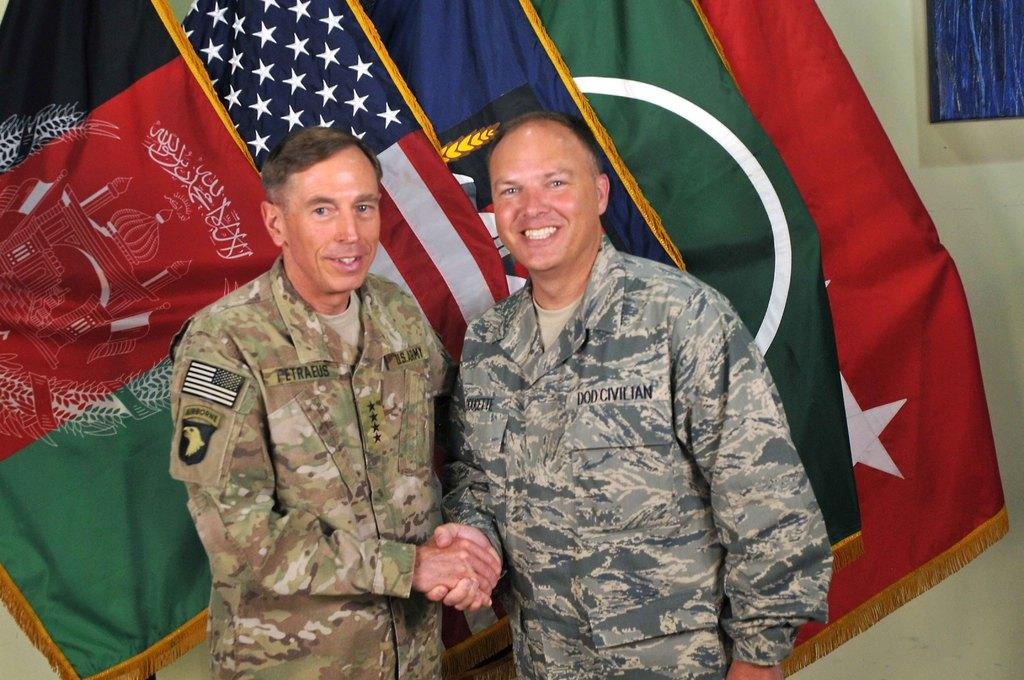How many people are present in the image? There are two people standing in the image. What can be seen in addition to the people? Flags and a wall are visible in the image. What is the color of the object on the wall? The object on the wall is blue. What type of juice is being served by the crow in the image? There is no crow or juice present in the image. 